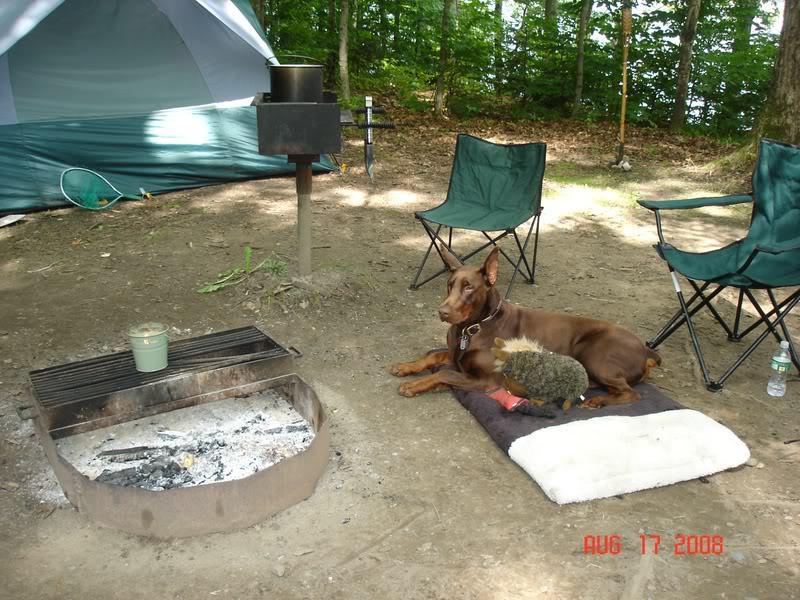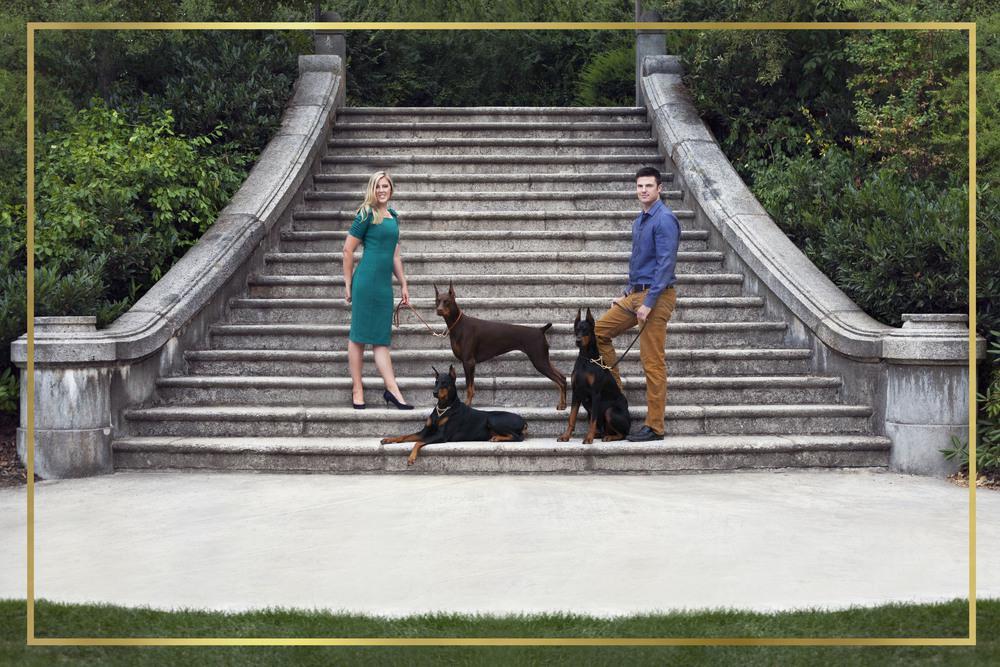The first image is the image on the left, the second image is the image on the right. Examine the images to the left and right. Is the description "A dog is laying on a blanket." accurate? Answer yes or no. Yes. 